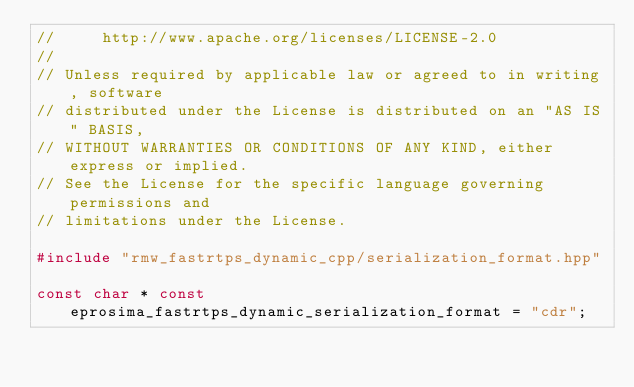Convert code to text. <code><loc_0><loc_0><loc_500><loc_500><_C++_>//     http://www.apache.org/licenses/LICENSE-2.0
//
// Unless required by applicable law or agreed to in writing, software
// distributed under the License is distributed on an "AS IS" BASIS,
// WITHOUT WARRANTIES OR CONDITIONS OF ANY KIND, either express or implied.
// See the License for the specific language governing permissions and
// limitations under the License.

#include "rmw_fastrtps_dynamic_cpp/serialization_format.hpp"

const char * const eprosima_fastrtps_dynamic_serialization_format = "cdr";
</code> 